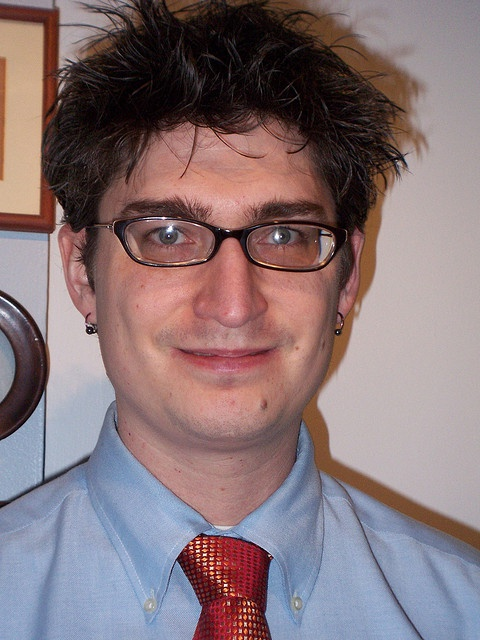Describe the objects in this image and their specific colors. I can see people in gray, black, brown, and darkgray tones and tie in gray, maroon, brown, and black tones in this image. 